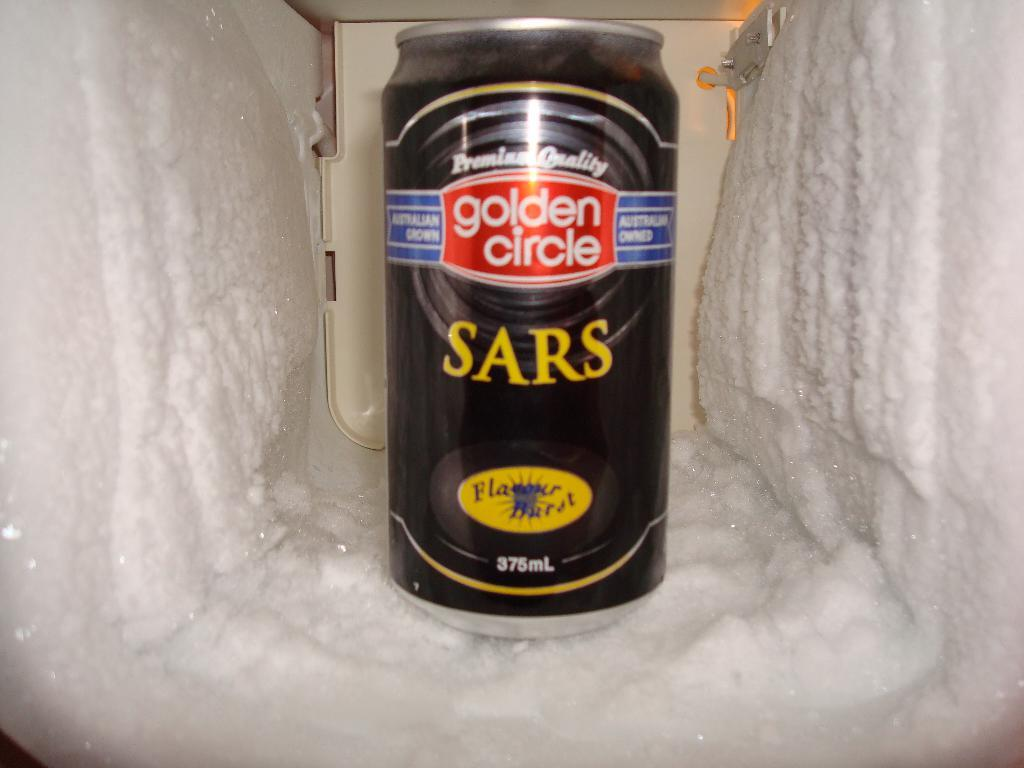<image>
Relay a brief, clear account of the picture shown. A Golden Circle branded can sits in a hole of frozen crust. 